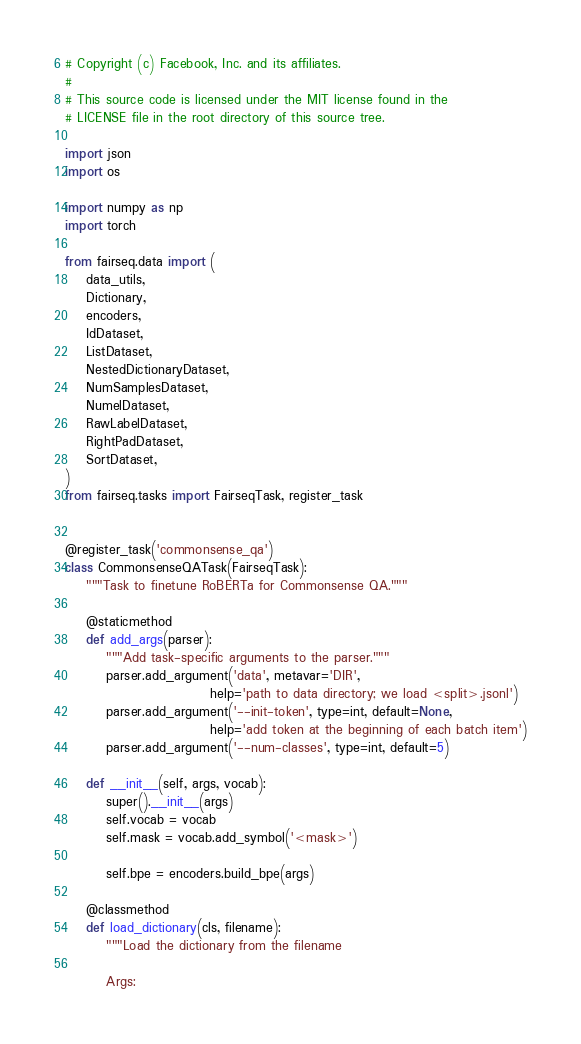Convert code to text. <code><loc_0><loc_0><loc_500><loc_500><_Python_># Copyright (c) Facebook, Inc. and its affiliates.
#
# This source code is licensed under the MIT license found in the
# LICENSE file in the root directory of this source tree.

import json
import os

import numpy as np
import torch

from fairseq.data import (
    data_utils,
    Dictionary,
    encoders,
    IdDataset,
    ListDataset,
    NestedDictionaryDataset,
    NumSamplesDataset,
    NumelDataset,
    RawLabelDataset,
    RightPadDataset,
    SortDataset,
)
from fairseq.tasks import FairseqTask, register_task


@register_task('commonsense_qa')
class CommonsenseQATask(FairseqTask):
    """Task to finetune RoBERTa for Commonsense QA."""

    @staticmethod
    def add_args(parser):
        """Add task-specific arguments to the parser."""
        parser.add_argument('data', metavar='DIR',
                            help='path to data directory; we load <split>.jsonl')
        parser.add_argument('--init-token', type=int, default=None,
                            help='add token at the beginning of each batch item')
        parser.add_argument('--num-classes', type=int, default=5)

    def __init__(self, args, vocab):
        super().__init__(args)
        self.vocab = vocab
        self.mask = vocab.add_symbol('<mask>')

        self.bpe = encoders.build_bpe(args)

    @classmethod
    def load_dictionary(cls, filename):
        """Load the dictionary from the filename

        Args:</code> 